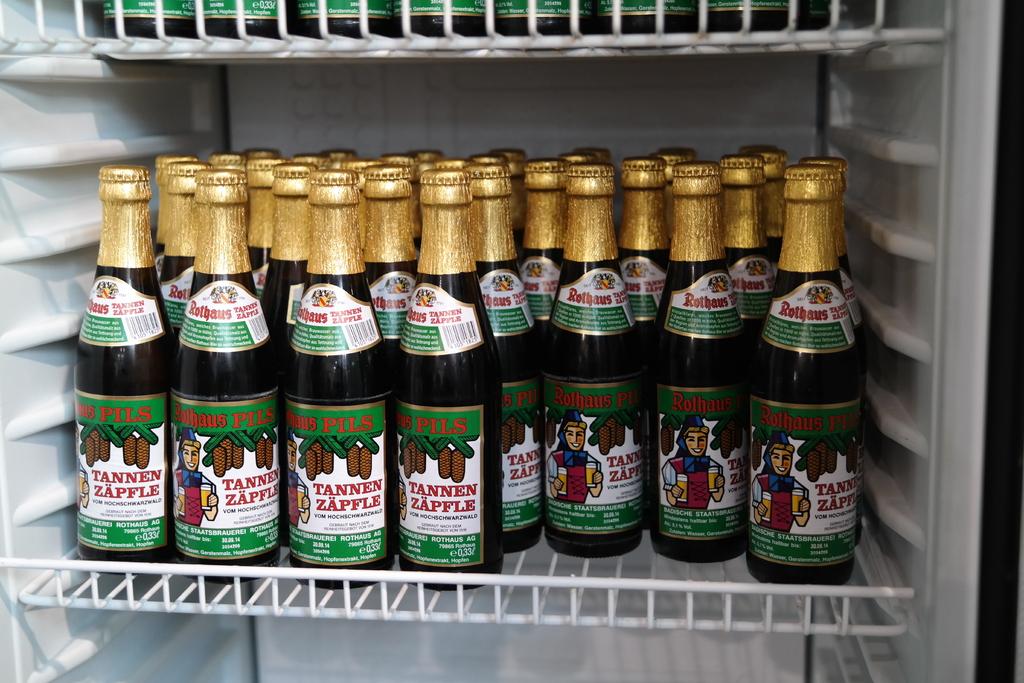What is the manufacturer of the drink?
Give a very brief answer. Rothaus. 